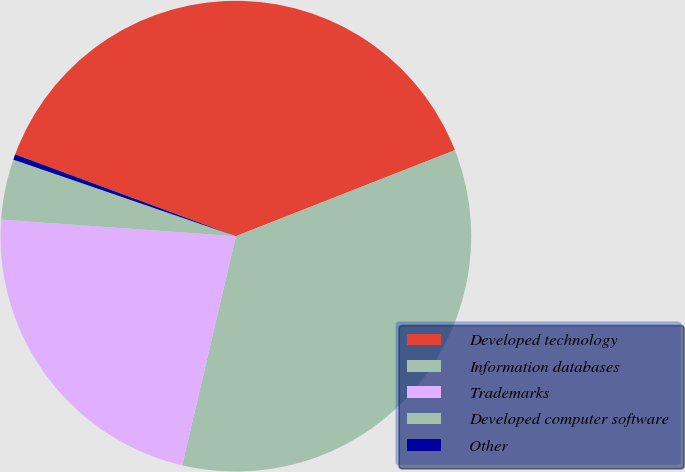<chart> <loc_0><loc_0><loc_500><loc_500><pie_chart><fcel>Developed technology<fcel>Information databases<fcel>Trademarks<fcel>Developed computer software<fcel>Other<nl><fcel>38.39%<fcel>34.62%<fcel>22.46%<fcel>4.15%<fcel>0.38%<nl></chart> 